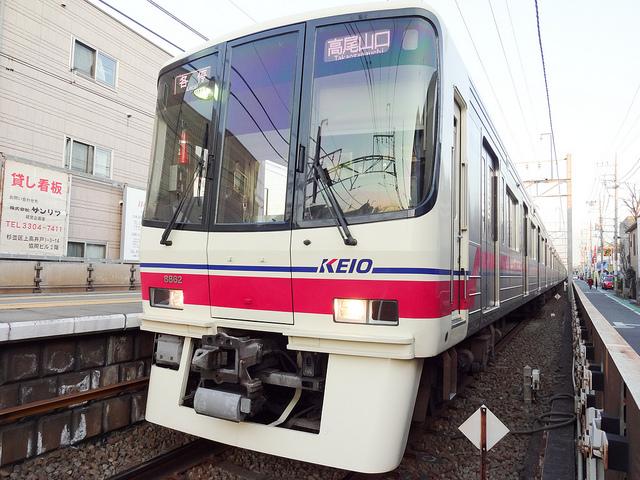Where are the windshield wipers?
Be succinct. On windshield. What color is the train?
Concise answer only. White. Is this the front of the back of the train?
Quick response, please. Front. Is this train in America?
Be succinct. No. 